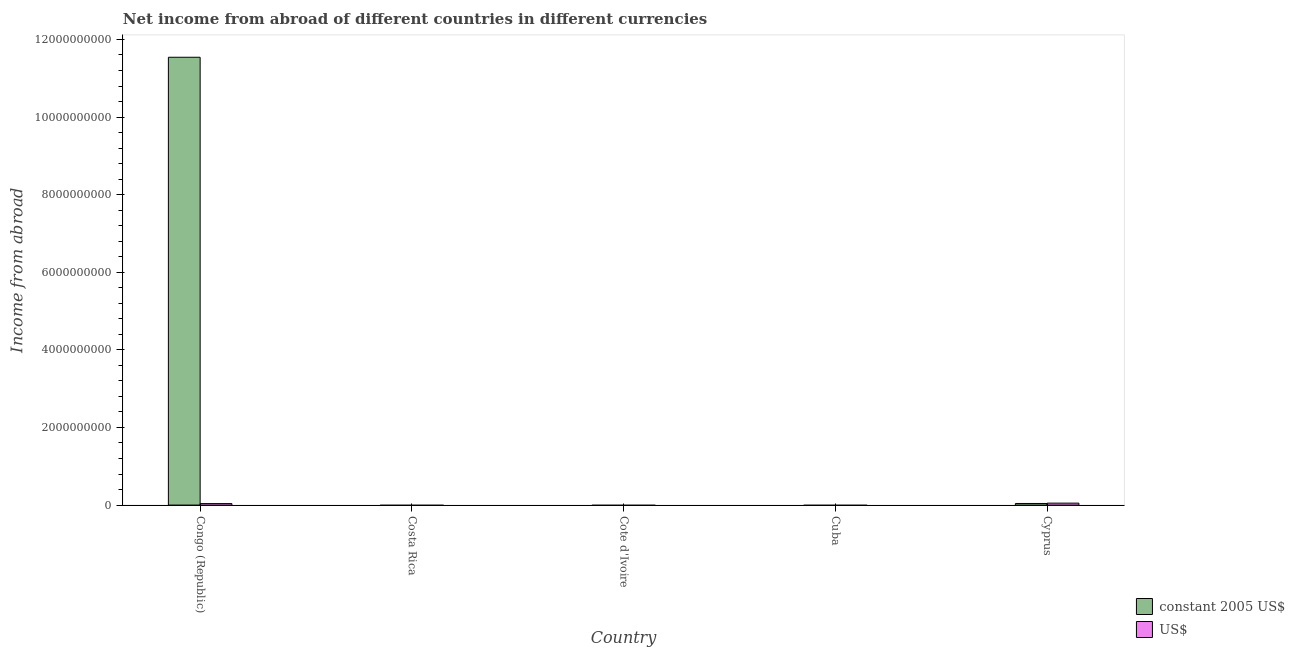How many different coloured bars are there?
Ensure brevity in your answer.  2. Are the number of bars per tick equal to the number of legend labels?
Provide a succinct answer. No. How many bars are there on the 4th tick from the left?
Provide a short and direct response. 0. What is the label of the 3rd group of bars from the left?
Make the answer very short. Cote d'Ivoire. What is the income from abroad in us$ in Cuba?
Offer a very short reply. 0. Across all countries, what is the maximum income from abroad in constant 2005 us$?
Keep it short and to the point. 1.15e+1. Across all countries, what is the minimum income from abroad in constant 2005 us$?
Give a very brief answer. 0. In which country was the income from abroad in constant 2005 us$ maximum?
Keep it short and to the point. Congo (Republic). What is the total income from abroad in us$ in the graph?
Ensure brevity in your answer.  8.86e+07. What is the difference between the income from abroad in us$ in Congo (Republic) and that in Cyprus?
Your response must be concise. -1.18e+07. What is the difference between the income from abroad in us$ in Cuba and the income from abroad in constant 2005 us$ in Cyprus?
Give a very brief answer. -4.12e+07. What is the average income from abroad in constant 2005 us$ per country?
Your answer should be very brief. 2.32e+09. What is the difference between the income from abroad in us$ and income from abroad in constant 2005 us$ in Congo (Republic)?
Keep it short and to the point. -1.15e+1. In how many countries, is the income from abroad in us$ greater than 8000000000 units?
Your response must be concise. 0. What is the difference between the highest and the lowest income from abroad in us$?
Offer a terse response. 5.02e+07. Is the sum of the income from abroad in constant 2005 us$ in Congo (Republic) and Cyprus greater than the maximum income from abroad in us$ across all countries?
Ensure brevity in your answer.  Yes. Are all the bars in the graph horizontal?
Your response must be concise. No. Are the values on the major ticks of Y-axis written in scientific E-notation?
Keep it short and to the point. No. Does the graph contain grids?
Make the answer very short. No. How many legend labels are there?
Make the answer very short. 2. How are the legend labels stacked?
Give a very brief answer. Vertical. What is the title of the graph?
Provide a succinct answer. Net income from abroad of different countries in different currencies. What is the label or title of the Y-axis?
Your response must be concise. Income from abroad. What is the Income from abroad in constant 2005 US$ in Congo (Republic)?
Your response must be concise. 1.15e+1. What is the Income from abroad in US$ in Congo (Republic)?
Provide a short and direct response. 3.84e+07. What is the Income from abroad of US$ in Costa Rica?
Your response must be concise. 0. What is the Income from abroad of constant 2005 US$ in Cyprus?
Offer a terse response. 4.12e+07. What is the Income from abroad in US$ in Cyprus?
Give a very brief answer. 5.02e+07. Across all countries, what is the maximum Income from abroad of constant 2005 US$?
Make the answer very short. 1.15e+1. Across all countries, what is the maximum Income from abroad of US$?
Offer a very short reply. 5.02e+07. Across all countries, what is the minimum Income from abroad of constant 2005 US$?
Offer a very short reply. 0. Across all countries, what is the minimum Income from abroad in US$?
Provide a succinct answer. 0. What is the total Income from abroad in constant 2005 US$ in the graph?
Offer a terse response. 1.16e+1. What is the total Income from abroad of US$ in the graph?
Your answer should be very brief. 8.86e+07. What is the difference between the Income from abroad in constant 2005 US$ in Congo (Republic) and that in Cyprus?
Your answer should be compact. 1.15e+1. What is the difference between the Income from abroad of US$ in Congo (Republic) and that in Cyprus?
Provide a succinct answer. -1.18e+07. What is the difference between the Income from abroad of constant 2005 US$ in Congo (Republic) and the Income from abroad of US$ in Cyprus?
Your response must be concise. 1.15e+1. What is the average Income from abroad of constant 2005 US$ per country?
Keep it short and to the point. 2.32e+09. What is the average Income from abroad of US$ per country?
Make the answer very short. 1.77e+07. What is the difference between the Income from abroad of constant 2005 US$ and Income from abroad of US$ in Congo (Republic)?
Offer a very short reply. 1.15e+1. What is the difference between the Income from abroad of constant 2005 US$ and Income from abroad of US$ in Cyprus?
Offer a very short reply. -8.98e+06. What is the ratio of the Income from abroad of constant 2005 US$ in Congo (Republic) to that in Cyprus?
Keep it short and to the point. 280.27. What is the ratio of the Income from abroad of US$ in Congo (Republic) to that in Cyprus?
Provide a short and direct response. 0.77. What is the difference between the highest and the lowest Income from abroad in constant 2005 US$?
Ensure brevity in your answer.  1.15e+1. What is the difference between the highest and the lowest Income from abroad in US$?
Your answer should be compact. 5.02e+07. 